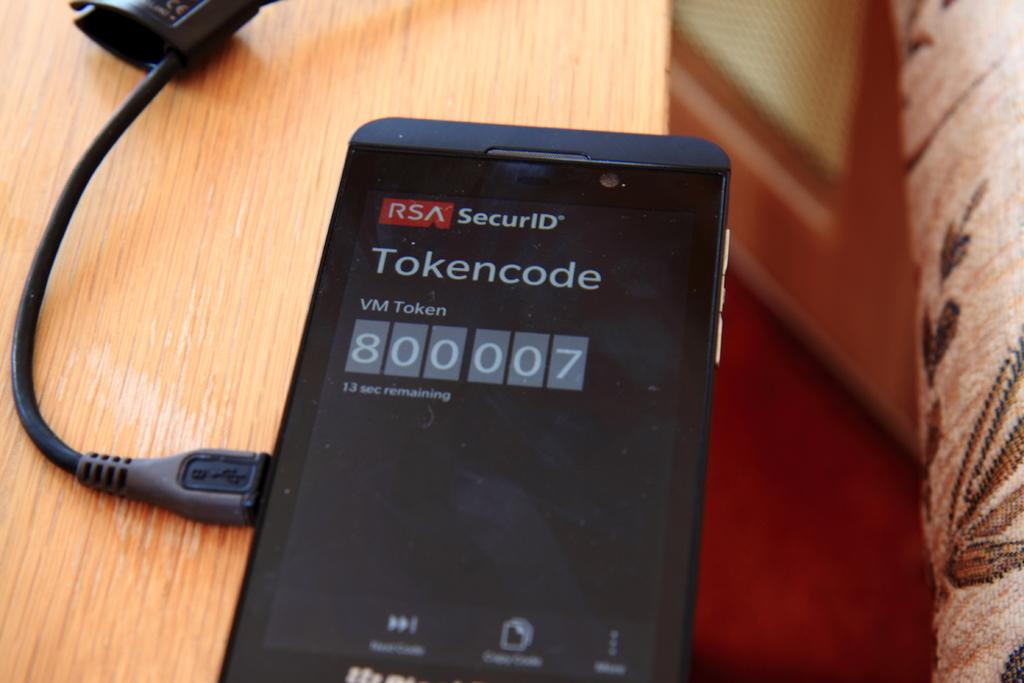<image>
Present a compact description of the photo's key features. An RSA SecurID terminal displays a Tokencode VM Token of 800007. 